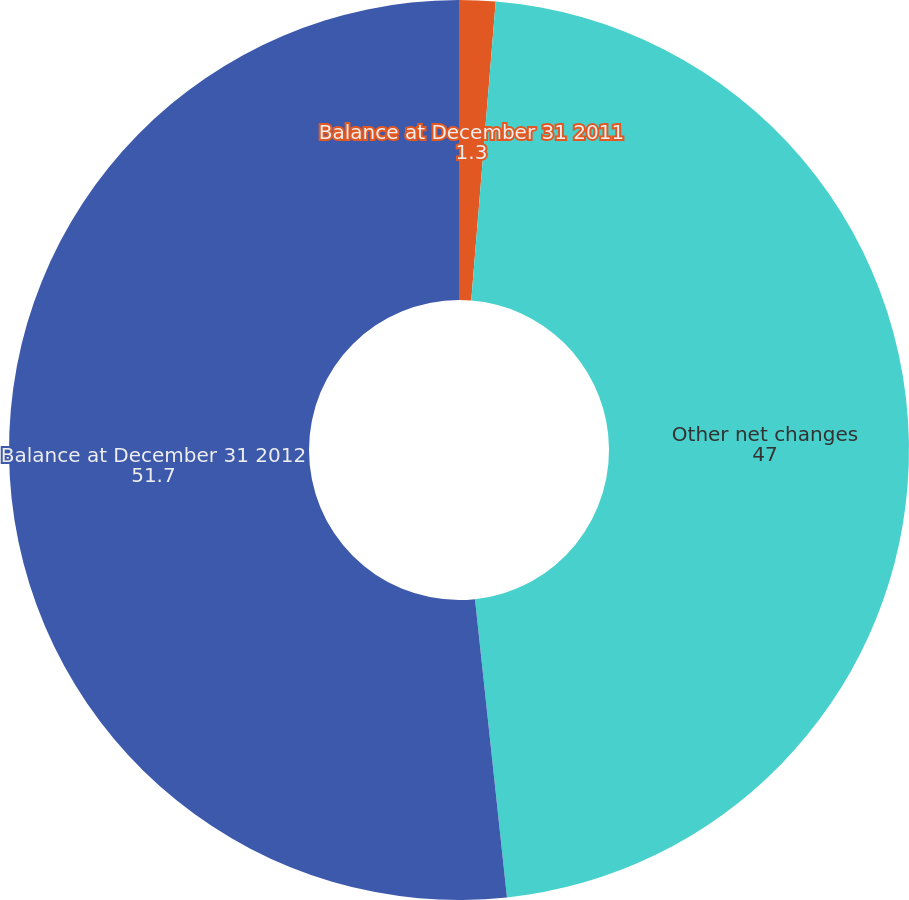Convert chart. <chart><loc_0><loc_0><loc_500><loc_500><pie_chart><fcel>Balance at December 31 2011<fcel>Other net changes<fcel>Balance at December 31 2012<nl><fcel>1.3%<fcel>47.0%<fcel>51.7%<nl></chart> 